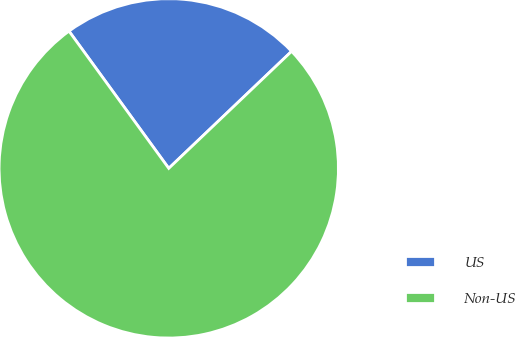Convert chart. <chart><loc_0><loc_0><loc_500><loc_500><pie_chart><fcel>US<fcel>Non-US<nl><fcel>22.89%<fcel>77.11%<nl></chart> 